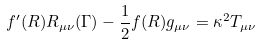<formula> <loc_0><loc_0><loc_500><loc_500>f ^ { \prime } ( R ) R _ { \mu \nu } ( \Gamma ) - \frac { 1 } { 2 } f ( R ) g _ { \mu \nu } = \kappa ^ { 2 } T _ { \mu \nu }</formula> 